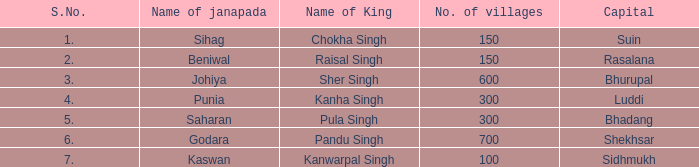Can you give me this table as a dict? {'header': ['S.No.', 'Name of janapada', 'Name of King', 'No. of villages', 'Capital'], 'rows': [['1.', 'Sihag', 'Chokha Singh', '150', 'Suin'], ['2.', 'Beniwal', 'Raisal Singh', '150', 'Rasalana'], ['3.', 'Johiya', 'Sher Singh', '600', 'Bhurupal'], ['4.', 'Punia', 'Kanha Singh', '300', 'Luddi'], ['5.', 'Saharan', 'Pula Singh', '300', 'Bhadang'], ['6.', 'Godara', 'Pandu Singh', '700', 'Shekhsar'], ['7.', 'Kaswan', 'Kanwarpal Singh', '100', 'Sidhmukh']]} Which capital has a serial number below 7 and is named janapada of punia? Luddi. 